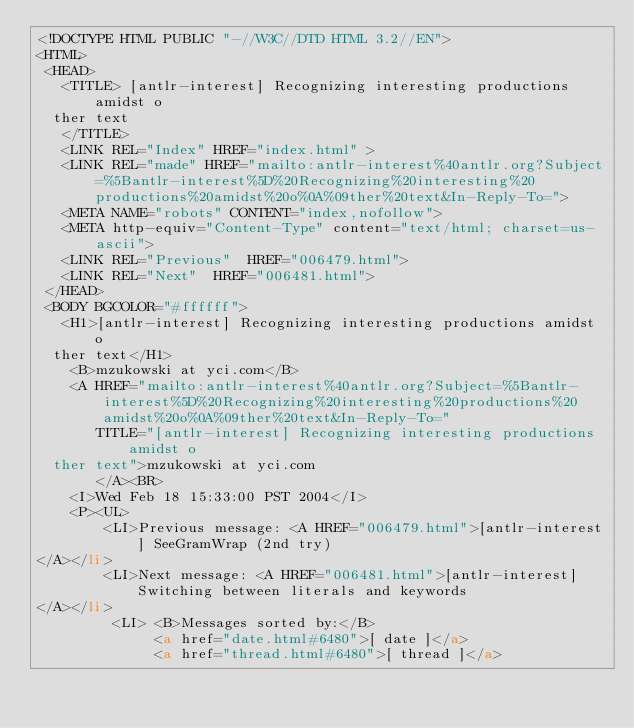<code> <loc_0><loc_0><loc_500><loc_500><_HTML_><!DOCTYPE HTML PUBLIC "-//W3C//DTD HTML 3.2//EN">
<HTML>
 <HEAD>
   <TITLE> [antlr-interest] Recognizing interesting productions amidst o
	ther text
   </TITLE>
   <LINK REL="Index" HREF="index.html" >
   <LINK REL="made" HREF="mailto:antlr-interest%40antlr.org?Subject=%5Bantlr-interest%5D%20Recognizing%20interesting%20productions%20amidst%20o%0A%09ther%20text&In-Reply-To=">
   <META NAME="robots" CONTENT="index,nofollow">
   <META http-equiv="Content-Type" content="text/html; charset=us-ascii">
   <LINK REL="Previous"  HREF="006479.html">
   <LINK REL="Next"  HREF="006481.html">
 </HEAD>
 <BODY BGCOLOR="#ffffff">
   <H1>[antlr-interest] Recognizing interesting productions amidst o
	ther text</H1>
    <B>mzukowski at yci.com</B> 
    <A HREF="mailto:antlr-interest%40antlr.org?Subject=%5Bantlr-interest%5D%20Recognizing%20interesting%20productions%20amidst%20o%0A%09ther%20text&In-Reply-To="
       TITLE="[antlr-interest] Recognizing interesting productions amidst o
	ther text">mzukowski at yci.com
       </A><BR>
    <I>Wed Feb 18 15:33:00 PST 2004</I>
    <P><UL>
        <LI>Previous message: <A HREF="006479.html">[antlr-interest] SeeGramWrap (2nd try)
</A></li>
        <LI>Next message: <A HREF="006481.html">[antlr-interest] Switching between literals and keywords
</A></li>
         <LI> <B>Messages sorted by:</B> 
              <a href="date.html#6480">[ date ]</a>
              <a href="thread.html#6480">[ thread ]</a></code> 